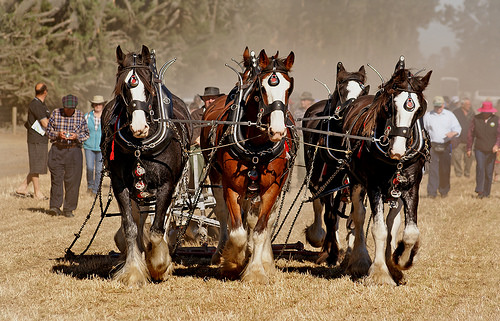<image>
Is the horse above the ground? Yes. The horse is positioned above the ground in the vertical space, higher up in the scene. Is the man behind the horse? Yes. From this viewpoint, the man is positioned behind the horse, with the horse partially or fully occluding the man. 